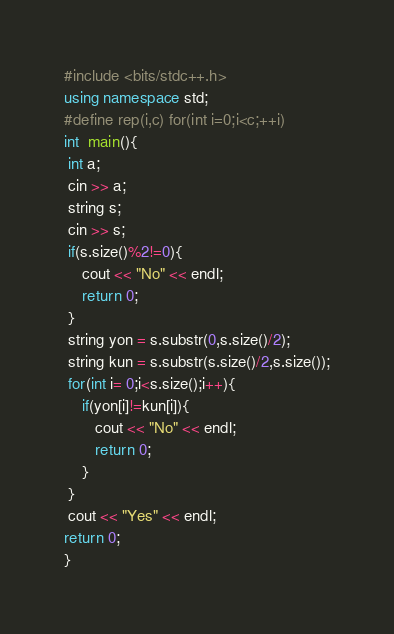<code> <loc_0><loc_0><loc_500><loc_500><_C++_>#include <bits/stdc++.h>
using namespace std;
#define rep(i,c) for(int i=0;i<c;++i)
int  main(){
 int a;
 cin >> a;
 string s;
 cin >> s;
 if(s.size()%2!=0){
    cout << "No" << endl;
    return 0;
 }
 string yon = s.substr(0,s.size()/2);
 string kun = s.substr(s.size()/2,s.size());
 for(int i= 0;i<s.size();i++){
    if(yon[i]!=kun[i]){
       cout << "No" << endl;
       return 0;
    }
 }
 cout << "Yes" << endl;
return 0;
}</code> 